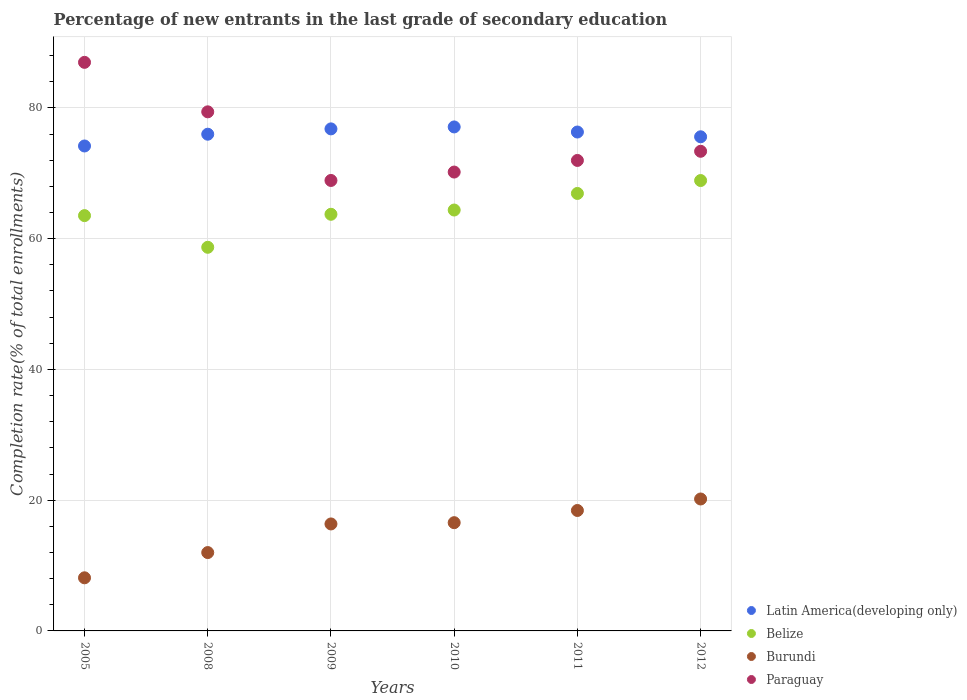How many different coloured dotlines are there?
Provide a short and direct response. 4. Is the number of dotlines equal to the number of legend labels?
Your answer should be compact. Yes. What is the percentage of new entrants in Latin America(developing only) in 2010?
Offer a terse response. 77.09. Across all years, what is the maximum percentage of new entrants in Paraguay?
Ensure brevity in your answer.  86.97. Across all years, what is the minimum percentage of new entrants in Burundi?
Your answer should be very brief. 8.12. In which year was the percentage of new entrants in Latin America(developing only) maximum?
Provide a succinct answer. 2010. What is the total percentage of new entrants in Latin America(developing only) in the graph?
Provide a short and direct response. 455.92. What is the difference between the percentage of new entrants in Belize in 2011 and that in 2012?
Make the answer very short. -1.97. What is the difference between the percentage of new entrants in Belize in 2009 and the percentage of new entrants in Burundi in 2008?
Give a very brief answer. 51.74. What is the average percentage of new entrants in Belize per year?
Your response must be concise. 64.35. In the year 2010, what is the difference between the percentage of new entrants in Latin America(developing only) and percentage of new entrants in Paraguay?
Ensure brevity in your answer.  6.9. In how many years, is the percentage of new entrants in Latin America(developing only) greater than 48 %?
Your response must be concise. 6. What is the ratio of the percentage of new entrants in Paraguay in 2011 to that in 2012?
Make the answer very short. 0.98. Is the difference between the percentage of new entrants in Latin America(developing only) in 2008 and 2011 greater than the difference between the percentage of new entrants in Paraguay in 2008 and 2011?
Offer a terse response. No. What is the difference between the highest and the second highest percentage of new entrants in Burundi?
Provide a succinct answer. 1.76. What is the difference between the highest and the lowest percentage of new entrants in Latin America(developing only)?
Make the answer very short. 2.91. Is the sum of the percentage of new entrants in Burundi in 2009 and 2012 greater than the maximum percentage of new entrants in Belize across all years?
Your response must be concise. No. Is it the case that in every year, the sum of the percentage of new entrants in Latin America(developing only) and percentage of new entrants in Paraguay  is greater than the sum of percentage of new entrants in Burundi and percentage of new entrants in Belize?
Your response must be concise. No. Does the percentage of new entrants in Belize monotonically increase over the years?
Your answer should be compact. No. Is the percentage of new entrants in Paraguay strictly less than the percentage of new entrants in Burundi over the years?
Make the answer very short. No. How many years are there in the graph?
Ensure brevity in your answer.  6. Does the graph contain grids?
Give a very brief answer. Yes. How are the legend labels stacked?
Provide a short and direct response. Vertical. What is the title of the graph?
Your answer should be very brief. Percentage of new entrants in the last grade of secondary education. Does "Monaco" appear as one of the legend labels in the graph?
Your answer should be very brief. No. What is the label or title of the Y-axis?
Offer a very short reply. Completion rate(% of total enrollments). What is the Completion rate(% of total enrollments) in Latin America(developing only) in 2005?
Ensure brevity in your answer.  74.18. What is the Completion rate(% of total enrollments) of Belize in 2005?
Keep it short and to the point. 63.52. What is the Completion rate(% of total enrollments) in Burundi in 2005?
Keep it short and to the point. 8.12. What is the Completion rate(% of total enrollments) of Paraguay in 2005?
Your response must be concise. 86.97. What is the Completion rate(% of total enrollments) of Latin America(developing only) in 2008?
Provide a short and direct response. 75.98. What is the Completion rate(% of total enrollments) in Belize in 2008?
Ensure brevity in your answer.  58.68. What is the Completion rate(% of total enrollments) in Burundi in 2008?
Make the answer very short. 11.98. What is the Completion rate(% of total enrollments) in Paraguay in 2008?
Ensure brevity in your answer.  79.4. What is the Completion rate(% of total enrollments) of Latin America(developing only) in 2009?
Make the answer very short. 76.79. What is the Completion rate(% of total enrollments) of Belize in 2009?
Ensure brevity in your answer.  63.73. What is the Completion rate(% of total enrollments) of Burundi in 2009?
Provide a short and direct response. 16.36. What is the Completion rate(% of total enrollments) of Paraguay in 2009?
Give a very brief answer. 68.9. What is the Completion rate(% of total enrollments) of Latin America(developing only) in 2010?
Give a very brief answer. 77.09. What is the Completion rate(% of total enrollments) of Belize in 2010?
Offer a very short reply. 64.38. What is the Completion rate(% of total enrollments) in Burundi in 2010?
Offer a terse response. 16.56. What is the Completion rate(% of total enrollments) of Paraguay in 2010?
Offer a very short reply. 70.19. What is the Completion rate(% of total enrollments) of Latin America(developing only) in 2011?
Your response must be concise. 76.31. What is the Completion rate(% of total enrollments) in Belize in 2011?
Keep it short and to the point. 66.91. What is the Completion rate(% of total enrollments) of Burundi in 2011?
Offer a terse response. 18.42. What is the Completion rate(% of total enrollments) in Paraguay in 2011?
Your answer should be very brief. 71.96. What is the Completion rate(% of total enrollments) of Latin America(developing only) in 2012?
Ensure brevity in your answer.  75.58. What is the Completion rate(% of total enrollments) of Belize in 2012?
Your answer should be very brief. 68.89. What is the Completion rate(% of total enrollments) in Burundi in 2012?
Your answer should be very brief. 20.18. What is the Completion rate(% of total enrollments) of Paraguay in 2012?
Offer a very short reply. 73.36. Across all years, what is the maximum Completion rate(% of total enrollments) in Latin America(developing only)?
Offer a very short reply. 77.09. Across all years, what is the maximum Completion rate(% of total enrollments) of Belize?
Keep it short and to the point. 68.89. Across all years, what is the maximum Completion rate(% of total enrollments) of Burundi?
Provide a succinct answer. 20.18. Across all years, what is the maximum Completion rate(% of total enrollments) of Paraguay?
Offer a very short reply. 86.97. Across all years, what is the minimum Completion rate(% of total enrollments) in Latin America(developing only)?
Give a very brief answer. 74.18. Across all years, what is the minimum Completion rate(% of total enrollments) of Belize?
Your response must be concise. 58.68. Across all years, what is the minimum Completion rate(% of total enrollments) in Burundi?
Ensure brevity in your answer.  8.12. Across all years, what is the minimum Completion rate(% of total enrollments) in Paraguay?
Your answer should be very brief. 68.9. What is the total Completion rate(% of total enrollments) of Latin America(developing only) in the graph?
Give a very brief answer. 455.92. What is the total Completion rate(% of total enrollments) of Belize in the graph?
Your answer should be very brief. 386.11. What is the total Completion rate(% of total enrollments) in Burundi in the graph?
Provide a succinct answer. 91.63. What is the total Completion rate(% of total enrollments) of Paraguay in the graph?
Keep it short and to the point. 450.78. What is the difference between the Completion rate(% of total enrollments) of Latin America(developing only) in 2005 and that in 2008?
Make the answer very short. -1.8. What is the difference between the Completion rate(% of total enrollments) in Belize in 2005 and that in 2008?
Offer a terse response. 4.84. What is the difference between the Completion rate(% of total enrollments) in Burundi in 2005 and that in 2008?
Keep it short and to the point. -3.86. What is the difference between the Completion rate(% of total enrollments) in Paraguay in 2005 and that in 2008?
Your answer should be very brief. 7.57. What is the difference between the Completion rate(% of total enrollments) of Latin America(developing only) in 2005 and that in 2009?
Offer a terse response. -2.61. What is the difference between the Completion rate(% of total enrollments) in Belize in 2005 and that in 2009?
Make the answer very short. -0.2. What is the difference between the Completion rate(% of total enrollments) in Burundi in 2005 and that in 2009?
Make the answer very short. -8.24. What is the difference between the Completion rate(% of total enrollments) of Paraguay in 2005 and that in 2009?
Your answer should be compact. 18.07. What is the difference between the Completion rate(% of total enrollments) in Latin America(developing only) in 2005 and that in 2010?
Provide a succinct answer. -2.91. What is the difference between the Completion rate(% of total enrollments) in Belize in 2005 and that in 2010?
Keep it short and to the point. -0.86. What is the difference between the Completion rate(% of total enrollments) in Burundi in 2005 and that in 2010?
Your answer should be very brief. -8.43. What is the difference between the Completion rate(% of total enrollments) in Paraguay in 2005 and that in 2010?
Your answer should be compact. 16.78. What is the difference between the Completion rate(% of total enrollments) in Latin America(developing only) in 2005 and that in 2011?
Your response must be concise. -2.13. What is the difference between the Completion rate(% of total enrollments) of Belize in 2005 and that in 2011?
Provide a succinct answer. -3.39. What is the difference between the Completion rate(% of total enrollments) of Burundi in 2005 and that in 2011?
Make the answer very short. -10.3. What is the difference between the Completion rate(% of total enrollments) in Paraguay in 2005 and that in 2011?
Keep it short and to the point. 15. What is the difference between the Completion rate(% of total enrollments) in Latin America(developing only) in 2005 and that in 2012?
Make the answer very short. -1.41. What is the difference between the Completion rate(% of total enrollments) in Belize in 2005 and that in 2012?
Your answer should be very brief. -5.36. What is the difference between the Completion rate(% of total enrollments) in Burundi in 2005 and that in 2012?
Your answer should be compact. -12.06. What is the difference between the Completion rate(% of total enrollments) of Paraguay in 2005 and that in 2012?
Your response must be concise. 13.6. What is the difference between the Completion rate(% of total enrollments) of Latin America(developing only) in 2008 and that in 2009?
Give a very brief answer. -0.82. What is the difference between the Completion rate(% of total enrollments) in Belize in 2008 and that in 2009?
Offer a terse response. -5.05. What is the difference between the Completion rate(% of total enrollments) of Burundi in 2008 and that in 2009?
Offer a very short reply. -4.38. What is the difference between the Completion rate(% of total enrollments) of Paraguay in 2008 and that in 2009?
Make the answer very short. 10.5. What is the difference between the Completion rate(% of total enrollments) of Latin America(developing only) in 2008 and that in 2010?
Provide a short and direct response. -1.11. What is the difference between the Completion rate(% of total enrollments) of Belize in 2008 and that in 2010?
Provide a succinct answer. -5.7. What is the difference between the Completion rate(% of total enrollments) of Burundi in 2008 and that in 2010?
Provide a succinct answer. -4.57. What is the difference between the Completion rate(% of total enrollments) in Paraguay in 2008 and that in 2010?
Make the answer very short. 9.21. What is the difference between the Completion rate(% of total enrollments) of Latin America(developing only) in 2008 and that in 2011?
Give a very brief answer. -0.34. What is the difference between the Completion rate(% of total enrollments) of Belize in 2008 and that in 2011?
Keep it short and to the point. -8.23. What is the difference between the Completion rate(% of total enrollments) in Burundi in 2008 and that in 2011?
Provide a succinct answer. -6.44. What is the difference between the Completion rate(% of total enrollments) in Paraguay in 2008 and that in 2011?
Make the answer very short. 7.44. What is the difference between the Completion rate(% of total enrollments) of Latin America(developing only) in 2008 and that in 2012?
Your answer should be compact. 0.39. What is the difference between the Completion rate(% of total enrollments) in Belize in 2008 and that in 2012?
Make the answer very short. -10.21. What is the difference between the Completion rate(% of total enrollments) in Burundi in 2008 and that in 2012?
Make the answer very short. -8.2. What is the difference between the Completion rate(% of total enrollments) of Paraguay in 2008 and that in 2012?
Your response must be concise. 6.04. What is the difference between the Completion rate(% of total enrollments) in Latin America(developing only) in 2009 and that in 2010?
Give a very brief answer. -0.3. What is the difference between the Completion rate(% of total enrollments) in Belize in 2009 and that in 2010?
Give a very brief answer. -0.65. What is the difference between the Completion rate(% of total enrollments) of Burundi in 2009 and that in 2010?
Your answer should be compact. -0.19. What is the difference between the Completion rate(% of total enrollments) in Paraguay in 2009 and that in 2010?
Provide a short and direct response. -1.29. What is the difference between the Completion rate(% of total enrollments) in Latin America(developing only) in 2009 and that in 2011?
Offer a terse response. 0.48. What is the difference between the Completion rate(% of total enrollments) in Belize in 2009 and that in 2011?
Offer a terse response. -3.19. What is the difference between the Completion rate(% of total enrollments) in Burundi in 2009 and that in 2011?
Give a very brief answer. -2.06. What is the difference between the Completion rate(% of total enrollments) of Paraguay in 2009 and that in 2011?
Give a very brief answer. -3.06. What is the difference between the Completion rate(% of total enrollments) of Latin America(developing only) in 2009 and that in 2012?
Offer a terse response. 1.21. What is the difference between the Completion rate(% of total enrollments) in Belize in 2009 and that in 2012?
Offer a very short reply. -5.16. What is the difference between the Completion rate(% of total enrollments) in Burundi in 2009 and that in 2012?
Give a very brief answer. -3.82. What is the difference between the Completion rate(% of total enrollments) in Paraguay in 2009 and that in 2012?
Your answer should be compact. -4.46. What is the difference between the Completion rate(% of total enrollments) of Latin America(developing only) in 2010 and that in 2011?
Offer a very short reply. 0.78. What is the difference between the Completion rate(% of total enrollments) in Belize in 2010 and that in 2011?
Your response must be concise. -2.54. What is the difference between the Completion rate(% of total enrollments) of Burundi in 2010 and that in 2011?
Offer a very short reply. -1.87. What is the difference between the Completion rate(% of total enrollments) of Paraguay in 2010 and that in 2011?
Offer a terse response. -1.78. What is the difference between the Completion rate(% of total enrollments) of Latin America(developing only) in 2010 and that in 2012?
Make the answer very short. 1.51. What is the difference between the Completion rate(% of total enrollments) in Belize in 2010 and that in 2012?
Your answer should be compact. -4.51. What is the difference between the Completion rate(% of total enrollments) in Burundi in 2010 and that in 2012?
Keep it short and to the point. -3.62. What is the difference between the Completion rate(% of total enrollments) of Paraguay in 2010 and that in 2012?
Your response must be concise. -3.18. What is the difference between the Completion rate(% of total enrollments) in Latin America(developing only) in 2011 and that in 2012?
Make the answer very short. 0.73. What is the difference between the Completion rate(% of total enrollments) in Belize in 2011 and that in 2012?
Give a very brief answer. -1.97. What is the difference between the Completion rate(% of total enrollments) of Burundi in 2011 and that in 2012?
Give a very brief answer. -1.76. What is the difference between the Completion rate(% of total enrollments) of Paraguay in 2011 and that in 2012?
Offer a terse response. -1.4. What is the difference between the Completion rate(% of total enrollments) in Latin America(developing only) in 2005 and the Completion rate(% of total enrollments) in Belize in 2008?
Offer a terse response. 15.5. What is the difference between the Completion rate(% of total enrollments) of Latin America(developing only) in 2005 and the Completion rate(% of total enrollments) of Burundi in 2008?
Your response must be concise. 62.19. What is the difference between the Completion rate(% of total enrollments) in Latin America(developing only) in 2005 and the Completion rate(% of total enrollments) in Paraguay in 2008?
Your answer should be compact. -5.22. What is the difference between the Completion rate(% of total enrollments) of Belize in 2005 and the Completion rate(% of total enrollments) of Burundi in 2008?
Provide a short and direct response. 51.54. What is the difference between the Completion rate(% of total enrollments) of Belize in 2005 and the Completion rate(% of total enrollments) of Paraguay in 2008?
Provide a short and direct response. -15.87. What is the difference between the Completion rate(% of total enrollments) in Burundi in 2005 and the Completion rate(% of total enrollments) in Paraguay in 2008?
Provide a succinct answer. -71.27. What is the difference between the Completion rate(% of total enrollments) in Latin America(developing only) in 2005 and the Completion rate(% of total enrollments) in Belize in 2009?
Give a very brief answer. 10.45. What is the difference between the Completion rate(% of total enrollments) of Latin America(developing only) in 2005 and the Completion rate(% of total enrollments) of Burundi in 2009?
Give a very brief answer. 57.81. What is the difference between the Completion rate(% of total enrollments) of Latin America(developing only) in 2005 and the Completion rate(% of total enrollments) of Paraguay in 2009?
Make the answer very short. 5.28. What is the difference between the Completion rate(% of total enrollments) of Belize in 2005 and the Completion rate(% of total enrollments) of Burundi in 2009?
Provide a short and direct response. 47.16. What is the difference between the Completion rate(% of total enrollments) in Belize in 2005 and the Completion rate(% of total enrollments) in Paraguay in 2009?
Offer a very short reply. -5.38. What is the difference between the Completion rate(% of total enrollments) in Burundi in 2005 and the Completion rate(% of total enrollments) in Paraguay in 2009?
Your answer should be compact. -60.78. What is the difference between the Completion rate(% of total enrollments) of Latin America(developing only) in 2005 and the Completion rate(% of total enrollments) of Belize in 2010?
Make the answer very short. 9.8. What is the difference between the Completion rate(% of total enrollments) in Latin America(developing only) in 2005 and the Completion rate(% of total enrollments) in Burundi in 2010?
Ensure brevity in your answer.  57.62. What is the difference between the Completion rate(% of total enrollments) in Latin America(developing only) in 2005 and the Completion rate(% of total enrollments) in Paraguay in 2010?
Provide a short and direct response. 3.99. What is the difference between the Completion rate(% of total enrollments) of Belize in 2005 and the Completion rate(% of total enrollments) of Burundi in 2010?
Offer a terse response. 46.97. What is the difference between the Completion rate(% of total enrollments) in Belize in 2005 and the Completion rate(% of total enrollments) in Paraguay in 2010?
Make the answer very short. -6.66. What is the difference between the Completion rate(% of total enrollments) of Burundi in 2005 and the Completion rate(% of total enrollments) of Paraguay in 2010?
Keep it short and to the point. -62.06. What is the difference between the Completion rate(% of total enrollments) of Latin America(developing only) in 2005 and the Completion rate(% of total enrollments) of Belize in 2011?
Keep it short and to the point. 7.26. What is the difference between the Completion rate(% of total enrollments) of Latin America(developing only) in 2005 and the Completion rate(% of total enrollments) of Burundi in 2011?
Your answer should be very brief. 55.75. What is the difference between the Completion rate(% of total enrollments) in Latin America(developing only) in 2005 and the Completion rate(% of total enrollments) in Paraguay in 2011?
Your response must be concise. 2.21. What is the difference between the Completion rate(% of total enrollments) in Belize in 2005 and the Completion rate(% of total enrollments) in Burundi in 2011?
Provide a short and direct response. 45.1. What is the difference between the Completion rate(% of total enrollments) in Belize in 2005 and the Completion rate(% of total enrollments) in Paraguay in 2011?
Ensure brevity in your answer.  -8.44. What is the difference between the Completion rate(% of total enrollments) of Burundi in 2005 and the Completion rate(% of total enrollments) of Paraguay in 2011?
Provide a short and direct response. -63.84. What is the difference between the Completion rate(% of total enrollments) in Latin America(developing only) in 2005 and the Completion rate(% of total enrollments) in Belize in 2012?
Ensure brevity in your answer.  5.29. What is the difference between the Completion rate(% of total enrollments) in Latin America(developing only) in 2005 and the Completion rate(% of total enrollments) in Burundi in 2012?
Ensure brevity in your answer.  53.99. What is the difference between the Completion rate(% of total enrollments) of Latin America(developing only) in 2005 and the Completion rate(% of total enrollments) of Paraguay in 2012?
Provide a succinct answer. 0.81. What is the difference between the Completion rate(% of total enrollments) of Belize in 2005 and the Completion rate(% of total enrollments) of Burundi in 2012?
Provide a succinct answer. 43.34. What is the difference between the Completion rate(% of total enrollments) in Belize in 2005 and the Completion rate(% of total enrollments) in Paraguay in 2012?
Give a very brief answer. -9.84. What is the difference between the Completion rate(% of total enrollments) in Burundi in 2005 and the Completion rate(% of total enrollments) in Paraguay in 2012?
Keep it short and to the point. -65.24. What is the difference between the Completion rate(% of total enrollments) of Latin America(developing only) in 2008 and the Completion rate(% of total enrollments) of Belize in 2009?
Make the answer very short. 12.25. What is the difference between the Completion rate(% of total enrollments) in Latin America(developing only) in 2008 and the Completion rate(% of total enrollments) in Burundi in 2009?
Make the answer very short. 59.61. What is the difference between the Completion rate(% of total enrollments) of Latin America(developing only) in 2008 and the Completion rate(% of total enrollments) of Paraguay in 2009?
Your answer should be very brief. 7.07. What is the difference between the Completion rate(% of total enrollments) of Belize in 2008 and the Completion rate(% of total enrollments) of Burundi in 2009?
Give a very brief answer. 42.32. What is the difference between the Completion rate(% of total enrollments) in Belize in 2008 and the Completion rate(% of total enrollments) in Paraguay in 2009?
Your answer should be very brief. -10.22. What is the difference between the Completion rate(% of total enrollments) of Burundi in 2008 and the Completion rate(% of total enrollments) of Paraguay in 2009?
Provide a short and direct response. -56.92. What is the difference between the Completion rate(% of total enrollments) of Latin America(developing only) in 2008 and the Completion rate(% of total enrollments) of Belize in 2010?
Make the answer very short. 11.6. What is the difference between the Completion rate(% of total enrollments) of Latin America(developing only) in 2008 and the Completion rate(% of total enrollments) of Burundi in 2010?
Keep it short and to the point. 59.42. What is the difference between the Completion rate(% of total enrollments) of Latin America(developing only) in 2008 and the Completion rate(% of total enrollments) of Paraguay in 2010?
Your response must be concise. 5.79. What is the difference between the Completion rate(% of total enrollments) in Belize in 2008 and the Completion rate(% of total enrollments) in Burundi in 2010?
Offer a very short reply. 42.12. What is the difference between the Completion rate(% of total enrollments) of Belize in 2008 and the Completion rate(% of total enrollments) of Paraguay in 2010?
Offer a terse response. -11.51. What is the difference between the Completion rate(% of total enrollments) of Burundi in 2008 and the Completion rate(% of total enrollments) of Paraguay in 2010?
Make the answer very short. -58.2. What is the difference between the Completion rate(% of total enrollments) in Latin America(developing only) in 2008 and the Completion rate(% of total enrollments) in Belize in 2011?
Provide a short and direct response. 9.06. What is the difference between the Completion rate(% of total enrollments) of Latin America(developing only) in 2008 and the Completion rate(% of total enrollments) of Burundi in 2011?
Offer a very short reply. 57.55. What is the difference between the Completion rate(% of total enrollments) in Latin America(developing only) in 2008 and the Completion rate(% of total enrollments) in Paraguay in 2011?
Your answer should be very brief. 4.01. What is the difference between the Completion rate(% of total enrollments) in Belize in 2008 and the Completion rate(% of total enrollments) in Burundi in 2011?
Your answer should be compact. 40.26. What is the difference between the Completion rate(% of total enrollments) in Belize in 2008 and the Completion rate(% of total enrollments) in Paraguay in 2011?
Offer a terse response. -13.28. What is the difference between the Completion rate(% of total enrollments) of Burundi in 2008 and the Completion rate(% of total enrollments) of Paraguay in 2011?
Your answer should be compact. -59.98. What is the difference between the Completion rate(% of total enrollments) of Latin America(developing only) in 2008 and the Completion rate(% of total enrollments) of Belize in 2012?
Give a very brief answer. 7.09. What is the difference between the Completion rate(% of total enrollments) of Latin America(developing only) in 2008 and the Completion rate(% of total enrollments) of Burundi in 2012?
Ensure brevity in your answer.  55.79. What is the difference between the Completion rate(% of total enrollments) of Latin America(developing only) in 2008 and the Completion rate(% of total enrollments) of Paraguay in 2012?
Provide a short and direct response. 2.61. What is the difference between the Completion rate(% of total enrollments) of Belize in 2008 and the Completion rate(% of total enrollments) of Burundi in 2012?
Your answer should be compact. 38.5. What is the difference between the Completion rate(% of total enrollments) in Belize in 2008 and the Completion rate(% of total enrollments) in Paraguay in 2012?
Give a very brief answer. -14.68. What is the difference between the Completion rate(% of total enrollments) of Burundi in 2008 and the Completion rate(% of total enrollments) of Paraguay in 2012?
Your response must be concise. -61.38. What is the difference between the Completion rate(% of total enrollments) of Latin America(developing only) in 2009 and the Completion rate(% of total enrollments) of Belize in 2010?
Make the answer very short. 12.41. What is the difference between the Completion rate(% of total enrollments) in Latin America(developing only) in 2009 and the Completion rate(% of total enrollments) in Burundi in 2010?
Offer a very short reply. 60.23. What is the difference between the Completion rate(% of total enrollments) in Latin America(developing only) in 2009 and the Completion rate(% of total enrollments) in Paraguay in 2010?
Offer a very short reply. 6.6. What is the difference between the Completion rate(% of total enrollments) of Belize in 2009 and the Completion rate(% of total enrollments) of Burundi in 2010?
Ensure brevity in your answer.  47.17. What is the difference between the Completion rate(% of total enrollments) of Belize in 2009 and the Completion rate(% of total enrollments) of Paraguay in 2010?
Keep it short and to the point. -6.46. What is the difference between the Completion rate(% of total enrollments) of Burundi in 2009 and the Completion rate(% of total enrollments) of Paraguay in 2010?
Keep it short and to the point. -53.82. What is the difference between the Completion rate(% of total enrollments) in Latin America(developing only) in 2009 and the Completion rate(% of total enrollments) in Belize in 2011?
Offer a very short reply. 9.88. What is the difference between the Completion rate(% of total enrollments) in Latin America(developing only) in 2009 and the Completion rate(% of total enrollments) in Burundi in 2011?
Keep it short and to the point. 58.37. What is the difference between the Completion rate(% of total enrollments) of Latin America(developing only) in 2009 and the Completion rate(% of total enrollments) of Paraguay in 2011?
Your response must be concise. 4.83. What is the difference between the Completion rate(% of total enrollments) of Belize in 2009 and the Completion rate(% of total enrollments) of Burundi in 2011?
Provide a short and direct response. 45.31. What is the difference between the Completion rate(% of total enrollments) in Belize in 2009 and the Completion rate(% of total enrollments) in Paraguay in 2011?
Give a very brief answer. -8.24. What is the difference between the Completion rate(% of total enrollments) of Burundi in 2009 and the Completion rate(% of total enrollments) of Paraguay in 2011?
Provide a short and direct response. -55.6. What is the difference between the Completion rate(% of total enrollments) in Latin America(developing only) in 2009 and the Completion rate(% of total enrollments) in Belize in 2012?
Keep it short and to the point. 7.9. What is the difference between the Completion rate(% of total enrollments) of Latin America(developing only) in 2009 and the Completion rate(% of total enrollments) of Burundi in 2012?
Your answer should be compact. 56.61. What is the difference between the Completion rate(% of total enrollments) of Latin America(developing only) in 2009 and the Completion rate(% of total enrollments) of Paraguay in 2012?
Ensure brevity in your answer.  3.43. What is the difference between the Completion rate(% of total enrollments) of Belize in 2009 and the Completion rate(% of total enrollments) of Burundi in 2012?
Offer a terse response. 43.55. What is the difference between the Completion rate(% of total enrollments) of Belize in 2009 and the Completion rate(% of total enrollments) of Paraguay in 2012?
Offer a terse response. -9.64. What is the difference between the Completion rate(% of total enrollments) in Burundi in 2009 and the Completion rate(% of total enrollments) in Paraguay in 2012?
Make the answer very short. -57. What is the difference between the Completion rate(% of total enrollments) of Latin America(developing only) in 2010 and the Completion rate(% of total enrollments) of Belize in 2011?
Your response must be concise. 10.17. What is the difference between the Completion rate(% of total enrollments) in Latin America(developing only) in 2010 and the Completion rate(% of total enrollments) in Burundi in 2011?
Ensure brevity in your answer.  58.67. What is the difference between the Completion rate(% of total enrollments) in Latin America(developing only) in 2010 and the Completion rate(% of total enrollments) in Paraguay in 2011?
Ensure brevity in your answer.  5.12. What is the difference between the Completion rate(% of total enrollments) of Belize in 2010 and the Completion rate(% of total enrollments) of Burundi in 2011?
Offer a terse response. 45.96. What is the difference between the Completion rate(% of total enrollments) in Belize in 2010 and the Completion rate(% of total enrollments) in Paraguay in 2011?
Give a very brief answer. -7.58. What is the difference between the Completion rate(% of total enrollments) in Burundi in 2010 and the Completion rate(% of total enrollments) in Paraguay in 2011?
Provide a short and direct response. -55.41. What is the difference between the Completion rate(% of total enrollments) of Latin America(developing only) in 2010 and the Completion rate(% of total enrollments) of Belize in 2012?
Offer a very short reply. 8.2. What is the difference between the Completion rate(% of total enrollments) in Latin America(developing only) in 2010 and the Completion rate(% of total enrollments) in Burundi in 2012?
Ensure brevity in your answer.  56.91. What is the difference between the Completion rate(% of total enrollments) in Latin America(developing only) in 2010 and the Completion rate(% of total enrollments) in Paraguay in 2012?
Your response must be concise. 3.73. What is the difference between the Completion rate(% of total enrollments) in Belize in 2010 and the Completion rate(% of total enrollments) in Burundi in 2012?
Your answer should be very brief. 44.2. What is the difference between the Completion rate(% of total enrollments) in Belize in 2010 and the Completion rate(% of total enrollments) in Paraguay in 2012?
Keep it short and to the point. -8.98. What is the difference between the Completion rate(% of total enrollments) of Burundi in 2010 and the Completion rate(% of total enrollments) of Paraguay in 2012?
Your response must be concise. -56.81. What is the difference between the Completion rate(% of total enrollments) of Latin America(developing only) in 2011 and the Completion rate(% of total enrollments) of Belize in 2012?
Your answer should be compact. 7.42. What is the difference between the Completion rate(% of total enrollments) in Latin America(developing only) in 2011 and the Completion rate(% of total enrollments) in Burundi in 2012?
Keep it short and to the point. 56.13. What is the difference between the Completion rate(% of total enrollments) in Latin America(developing only) in 2011 and the Completion rate(% of total enrollments) in Paraguay in 2012?
Provide a succinct answer. 2.95. What is the difference between the Completion rate(% of total enrollments) in Belize in 2011 and the Completion rate(% of total enrollments) in Burundi in 2012?
Offer a very short reply. 46.73. What is the difference between the Completion rate(% of total enrollments) in Belize in 2011 and the Completion rate(% of total enrollments) in Paraguay in 2012?
Provide a succinct answer. -6.45. What is the difference between the Completion rate(% of total enrollments) of Burundi in 2011 and the Completion rate(% of total enrollments) of Paraguay in 2012?
Offer a terse response. -54.94. What is the average Completion rate(% of total enrollments) of Latin America(developing only) per year?
Make the answer very short. 75.99. What is the average Completion rate(% of total enrollments) of Belize per year?
Provide a succinct answer. 64.35. What is the average Completion rate(% of total enrollments) in Burundi per year?
Provide a short and direct response. 15.27. What is the average Completion rate(% of total enrollments) of Paraguay per year?
Provide a short and direct response. 75.13. In the year 2005, what is the difference between the Completion rate(% of total enrollments) in Latin America(developing only) and Completion rate(% of total enrollments) in Belize?
Ensure brevity in your answer.  10.65. In the year 2005, what is the difference between the Completion rate(% of total enrollments) in Latin America(developing only) and Completion rate(% of total enrollments) in Burundi?
Give a very brief answer. 66.05. In the year 2005, what is the difference between the Completion rate(% of total enrollments) of Latin America(developing only) and Completion rate(% of total enrollments) of Paraguay?
Your answer should be compact. -12.79. In the year 2005, what is the difference between the Completion rate(% of total enrollments) of Belize and Completion rate(% of total enrollments) of Burundi?
Offer a very short reply. 55.4. In the year 2005, what is the difference between the Completion rate(% of total enrollments) in Belize and Completion rate(% of total enrollments) in Paraguay?
Offer a terse response. -23.44. In the year 2005, what is the difference between the Completion rate(% of total enrollments) of Burundi and Completion rate(% of total enrollments) of Paraguay?
Your response must be concise. -78.84. In the year 2008, what is the difference between the Completion rate(% of total enrollments) in Latin America(developing only) and Completion rate(% of total enrollments) in Belize?
Your response must be concise. 17.3. In the year 2008, what is the difference between the Completion rate(% of total enrollments) in Latin America(developing only) and Completion rate(% of total enrollments) in Burundi?
Your answer should be compact. 63.99. In the year 2008, what is the difference between the Completion rate(% of total enrollments) of Latin America(developing only) and Completion rate(% of total enrollments) of Paraguay?
Your answer should be very brief. -3.42. In the year 2008, what is the difference between the Completion rate(% of total enrollments) of Belize and Completion rate(% of total enrollments) of Burundi?
Your response must be concise. 46.69. In the year 2008, what is the difference between the Completion rate(% of total enrollments) in Belize and Completion rate(% of total enrollments) in Paraguay?
Give a very brief answer. -20.72. In the year 2008, what is the difference between the Completion rate(% of total enrollments) of Burundi and Completion rate(% of total enrollments) of Paraguay?
Offer a very short reply. -67.41. In the year 2009, what is the difference between the Completion rate(% of total enrollments) in Latin America(developing only) and Completion rate(% of total enrollments) in Belize?
Offer a very short reply. 13.06. In the year 2009, what is the difference between the Completion rate(% of total enrollments) of Latin America(developing only) and Completion rate(% of total enrollments) of Burundi?
Give a very brief answer. 60.43. In the year 2009, what is the difference between the Completion rate(% of total enrollments) of Latin America(developing only) and Completion rate(% of total enrollments) of Paraguay?
Offer a very short reply. 7.89. In the year 2009, what is the difference between the Completion rate(% of total enrollments) of Belize and Completion rate(% of total enrollments) of Burundi?
Your response must be concise. 47.36. In the year 2009, what is the difference between the Completion rate(% of total enrollments) of Belize and Completion rate(% of total enrollments) of Paraguay?
Your answer should be compact. -5.17. In the year 2009, what is the difference between the Completion rate(% of total enrollments) of Burundi and Completion rate(% of total enrollments) of Paraguay?
Your answer should be compact. -52.54. In the year 2010, what is the difference between the Completion rate(% of total enrollments) of Latin America(developing only) and Completion rate(% of total enrollments) of Belize?
Your answer should be very brief. 12.71. In the year 2010, what is the difference between the Completion rate(% of total enrollments) in Latin America(developing only) and Completion rate(% of total enrollments) in Burundi?
Make the answer very short. 60.53. In the year 2010, what is the difference between the Completion rate(% of total enrollments) of Latin America(developing only) and Completion rate(% of total enrollments) of Paraguay?
Offer a very short reply. 6.9. In the year 2010, what is the difference between the Completion rate(% of total enrollments) of Belize and Completion rate(% of total enrollments) of Burundi?
Keep it short and to the point. 47.82. In the year 2010, what is the difference between the Completion rate(% of total enrollments) of Belize and Completion rate(% of total enrollments) of Paraguay?
Give a very brief answer. -5.81. In the year 2010, what is the difference between the Completion rate(% of total enrollments) in Burundi and Completion rate(% of total enrollments) in Paraguay?
Your response must be concise. -53.63. In the year 2011, what is the difference between the Completion rate(% of total enrollments) of Latin America(developing only) and Completion rate(% of total enrollments) of Belize?
Provide a short and direct response. 9.4. In the year 2011, what is the difference between the Completion rate(% of total enrollments) of Latin America(developing only) and Completion rate(% of total enrollments) of Burundi?
Keep it short and to the point. 57.89. In the year 2011, what is the difference between the Completion rate(% of total enrollments) in Latin America(developing only) and Completion rate(% of total enrollments) in Paraguay?
Keep it short and to the point. 4.35. In the year 2011, what is the difference between the Completion rate(% of total enrollments) in Belize and Completion rate(% of total enrollments) in Burundi?
Provide a succinct answer. 48.49. In the year 2011, what is the difference between the Completion rate(% of total enrollments) in Belize and Completion rate(% of total enrollments) in Paraguay?
Keep it short and to the point. -5.05. In the year 2011, what is the difference between the Completion rate(% of total enrollments) of Burundi and Completion rate(% of total enrollments) of Paraguay?
Ensure brevity in your answer.  -53.54. In the year 2012, what is the difference between the Completion rate(% of total enrollments) in Latin America(developing only) and Completion rate(% of total enrollments) in Belize?
Your answer should be compact. 6.69. In the year 2012, what is the difference between the Completion rate(% of total enrollments) in Latin America(developing only) and Completion rate(% of total enrollments) in Burundi?
Keep it short and to the point. 55.4. In the year 2012, what is the difference between the Completion rate(% of total enrollments) of Latin America(developing only) and Completion rate(% of total enrollments) of Paraguay?
Your answer should be compact. 2.22. In the year 2012, what is the difference between the Completion rate(% of total enrollments) of Belize and Completion rate(% of total enrollments) of Burundi?
Make the answer very short. 48.71. In the year 2012, what is the difference between the Completion rate(% of total enrollments) in Belize and Completion rate(% of total enrollments) in Paraguay?
Offer a very short reply. -4.47. In the year 2012, what is the difference between the Completion rate(% of total enrollments) of Burundi and Completion rate(% of total enrollments) of Paraguay?
Provide a succinct answer. -53.18. What is the ratio of the Completion rate(% of total enrollments) of Latin America(developing only) in 2005 to that in 2008?
Ensure brevity in your answer.  0.98. What is the ratio of the Completion rate(% of total enrollments) of Belize in 2005 to that in 2008?
Offer a very short reply. 1.08. What is the ratio of the Completion rate(% of total enrollments) in Burundi in 2005 to that in 2008?
Make the answer very short. 0.68. What is the ratio of the Completion rate(% of total enrollments) of Paraguay in 2005 to that in 2008?
Your answer should be very brief. 1.1. What is the ratio of the Completion rate(% of total enrollments) of Burundi in 2005 to that in 2009?
Provide a short and direct response. 0.5. What is the ratio of the Completion rate(% of total enrollments) of Paraguay in 2005 to that in 2009?
Your answer should be compact. 1.26. What is the ratio of the Completion rate(% of total enrollments) in Latin America(developing only) in 2005 to that in 2010?
Ensure brevity in your answer.  0.96. What is the ratio of the Completion rate(% of total enrollments) of Belize in 2005 to that in 2010?
Your answer should be very brief. 0.99. What is the ratio of the Completion rate(% of total enrollments) in Burundi in 2005 to that in 2010?
Offer a terse response. 0.49. What is the ratio of the Completion rate(% of total enrollments) of Paraguay in 2005 to that in 2010?
Ensure brevity in your answer.  1.24. What is the ratio of the Completion rate(% of total enrollments) of Latin America(developing only) in 2005 to that in 2011?
Provide a short and direct response. 0.97. What is the ratio of the Completion rate(% of total enrollments) in Belize in 2005 to that in 2011?
Provide a succinct answer. 0.95. What is the ratio of the Completion rate(% of total enrollments) of Burundi in 2005 to that in 2011?
Offer a terse response. 0.44. What is the ratio of the Completion rate(% of total enrollments) of Paraguay in 2005 to that in 2011?
Offer a very short reply. 1.21. What is the ratio of the Completion rate(% of total enrollments) in Latin America(developing only) in 2005 to that in 2012?
Make the answer very short. 0.98. What is the ratio of the Completion rate(% of total enrollments) in Belize in 2005 to that in 2012?
Your answer should be very brief. 0.92. What is the ratio of the Completion rate(% of total enrollments) of Burundi in 2005 to that in 2012?
Provide a succinct answer. 0.4. What is the ratio of the Completion rate(% of total enrollments) in Paraguay in 2005 to that in 2012?
Make the answer very short. 1.19. What is the ratio of the Completion rate(% of total enrollments) of Latin America(developing only) in 2008 to that in 2009?
Keep it short and to the point. 0.99. What is the ratio of the Completion rate(% of total enrollments) of Belize in 2008 to that in 2009?
Provide a short and direct response. 0.92. What is the ratio of the Completion rate(% of total enrollments) in Burundi in 2008 to that in 2009?
Provide a short and direct response. 0.73. What is the ratio of the Completion rate(% of total enrollments) in Paraguay in 2008 to that in 2009?
Ensure brevity in your answer.  1.15. What is the ratio of the Completion rate(% of total enrollments) of Latin America(developing only) in 2008 to that in 2010?
Your response must be concise. 0.99. What is the ratio of the Completion rate(% of total enrollments) of Belize in 2008 to that in 2010?
Offer a very short reply. 0.91. What is the ratio of the Completion rate(% of total enrollments) in Burundi in 2008 to that in 2010?
Provide a short and direct response. 0.72. What is the ratio of the Completion rate(% of total enrollments) of Paraguay in 2008 to that in 2010?
Keep it short and to the point. 1.13. What is the ratio of the Completion rate(% of total enrollments) in Latin America(developing only) in 2008 to that in 2011?
Offer a very short reply. 1. What is the ratio of the Completion rate(% of total enrollments) in Belize in 2008 to that in 2011?
Provide a succinct answer. 0.88. What is the ratio of the Completion rate(% of total enrollments) of Burundi in 2008 to that in 2011?
Give a very brief answer. 0.65. What is the ratio of the Completion rate(% of total enrollments) in Paraguay in 2008 to that in 2011?
Offer a very short reply. 1.1. What is the ratio of the Completion rate(% of total enrollments) of Latin America(developing only) in 2008 to that in 2012?
Your answer should be compact. 1.01. What is the ratio of the Completion rate(% of total enrollments) of Belize in 2008 to that in 2012?
Provide a succinct answer. 0.85. What is the ratio of the Completion rate(% of total enrollments) in Burundi in 2008 to that in 2012?
Keep it short and to the point. 0.59. What is the ratio of the Completion rate(% of total enrollments) of Paraguay in 2008 to that in 2012?
Offer a very short reply. 1.08. What is the ratio of the Completion rate(% of total enrollments) in Belize in 2009 to that in 2010?
Offer a very short reply. 0.99. What is the ratio of the Completion rate(% of total enrollments) in Burundi in 2009 to that in 2010?
Give a very brief answer. 0.99. What is the ratio of the Completion rate(% of total enrollments) of Paraguay in 2009 to that in 2010?
Keep it short and to the point. 0.98. What is the ratio of the Completion rate(% of total enrollments) in Latin America(developing only) in 2009 to that in 2011?
Give a very brief answer. 1.01. What is the ratio of the Completion rate(% of total enrollments) in Burundi in 2009 to that in 2011?
Offer a terse response. 0.89. What is the ratio of the Completion rate(% of total enrollments) in Paraguay in 2009 to that in 2011?
Offer a terse response. 0.96. What is the ratio of the Completion rate(% of total enrollments) in Belize in 2009 to that in 2012?
Keep it short and to the point. 0.93. What is the ratio of the Completion rate(% of total enrollments) of Burundi in 2009 to that in 2012?
Offer a terse response. 0.81. What is the ratio of the Completion rate(% of total enrollments) in Paraguay in 2009 to that in 2012?
Your response must be concise. 0.94. What is the ratio of the Completion rate(% of total enrollments) of Latin America(developing only) in 2010 to that in 2011?
Your response must be concise. 1.01. What is the ratio of the Completion rate(% of total enrollments) of Belize in 2010 to that in 2011?
Keep it short and to the point. 0.96. What is the ratio of the Completion rate(% of total enrollments) in Burundi in 2010 to that in 2011?
Your response must be concise. 0.9. What is the ratio of the Completion rate(% of total enrollments) in Paraguay in 2010 to that in 2011?
Give a very brief answer. 0.98. What is the ratio of the Completion rate(% of total enrollments) of Latin America(developing only) in 2010 to that in 2012?
Your answer should be compact. 1.02. What is the ratio of the Completion rate(% of total enrollments) in Belize in 2010 to that in 2012?
Your answer should be very brief. 0.93. What is the ratio of the Completion rate(% of total enrollments) in Burundi in 2010 to that in 2012?
Offer a very short reply. 0.82. What is the ratio of the Completion rate(% of total enrollments) in Paraguay in 2010 to that in 2012?
Make the answer very short. 0.96. What is the ratio of the Completion rate(% of total enrollments) in Latin America(developing only) in 2011 to that in 2012?
Offer a very short reply. 1.01. What is the ratio of the Completion rate(% of total enrollments) in Belize in 2011 to that in 2012?
Your response must be concise. 0.97. What is the ratio of the Completion rate(% of total enrollments) in Burundi in 2011 to that in 2012?
Keep it short and to the point. 0.91. What is the ratio of the Completion rate(% of total enrollments) in Paraguay in 2011 to that in 2012?
Make the answer very short. 0.98. What is the difference between the highest and the second highest Completion rate(% of total enrollments) in Latin America(developing only)?
Offer a very short reply. 0.3. What is the difference between the highest and the second highest Completion rate(% of total enrollments) in Belize?
Offer a terse response. 1.97. What is the difference between the highest and the second highest Completion rate(% of total enrollments) in Burundi?
Offer a very short reply. 1.76. What is the difference between the highest and the second highest Completion rate(% of total enrollments) of Paraguay?
Give a very brief answer. 7.57. What is the difference between the highest and the lowest Completion rate(% of total enrollments) in Latin America(developing only)?
Your response must be concise. 2.91. What is the difference between the highest and the lowest Completion rate(% of total enrollments) of Belize?
Your answer should be very brief. 10.21. What is the difference between the highest and the lowest Completion rate(% of total enrollments) in Burundi?
Offer a terse response. 12.06. What is the difference between the highest and the lowest Completion rate(% of total enrollments) of Paraguay?
Your answer should be compact. 18.07. 